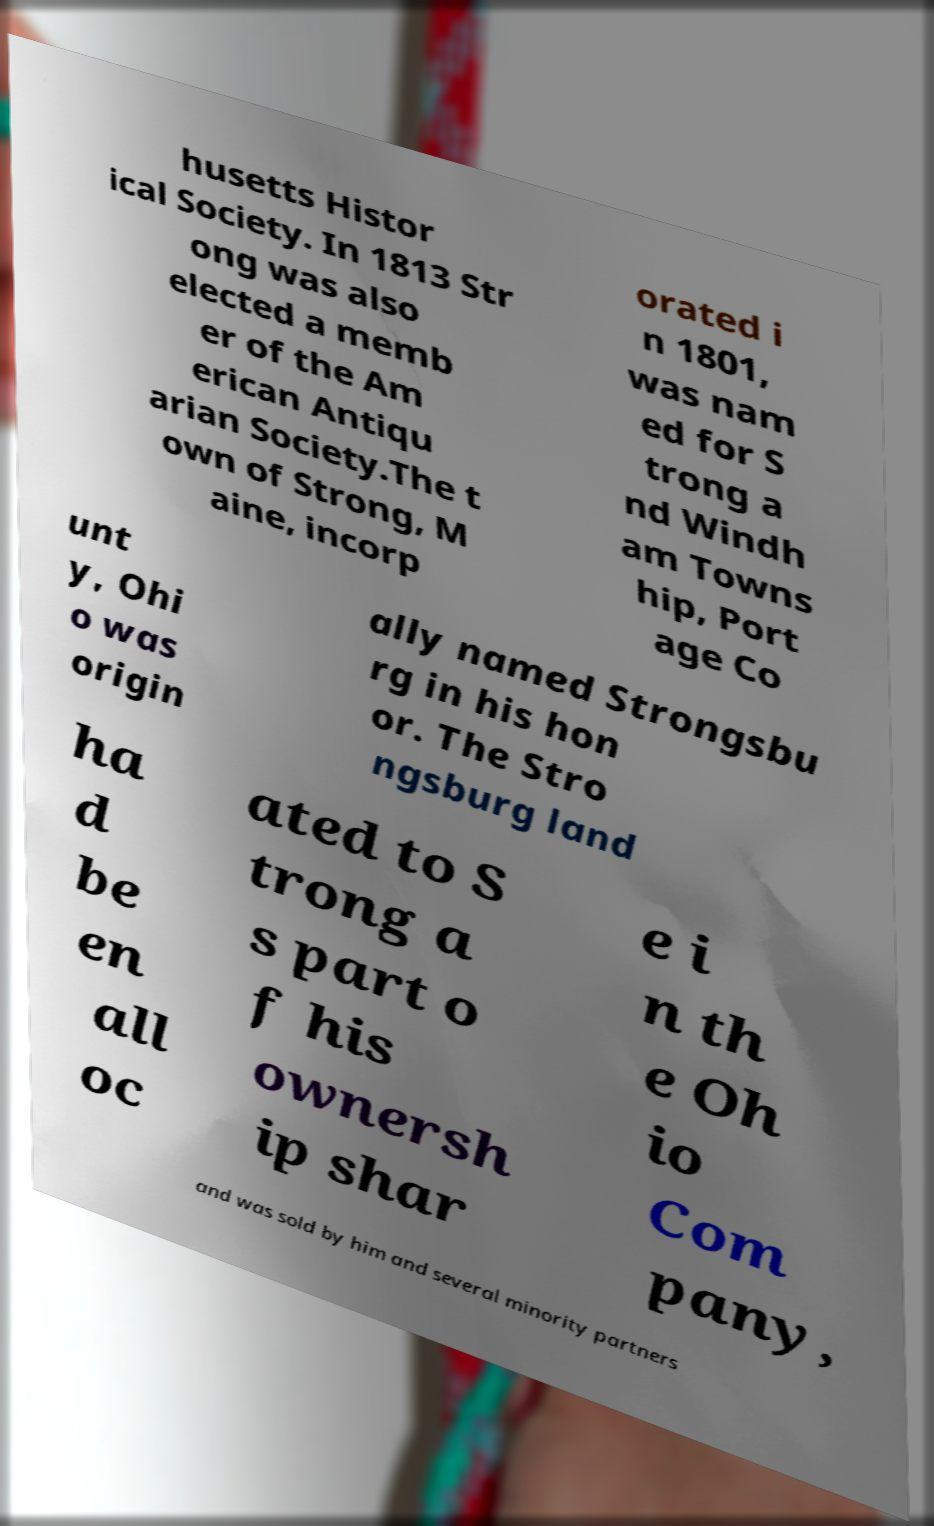What messages or text are displayed in this image? I need them in a readable, typed format. husetts Histor ical Society. In 1813 Str ong was also elected a memb er of the Am erican Antiqu arian Society.The t own of Strong, M aine, incorp orated i n 1801, was nam ed for S trong a nd Windh am Towns hip, Port age Co unt y, Ohi o was origin ally named Strongsbu rg in his hon or. The Stro ngsburg land ha d be en all oc ated to S trong a s part o f his ownersh ip shar e i n th e Oh io Com pany, and was sold by him and several minority partners 